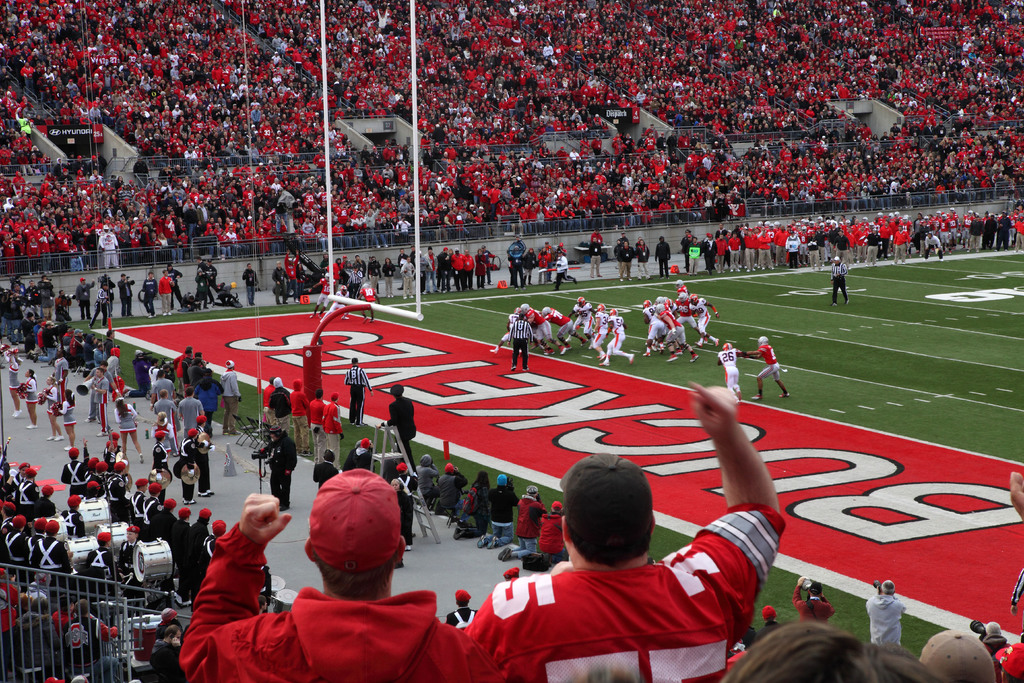How do the fans contribute to the atmosphere at the game? The fans are a vital part of the atmosphere, their collective spirit and passion evident in the sea of red attire, cheers, and focused attention on the unfolding game. They create a united and thrilling environment that boosts the players' morale and exemplifies the cultural phenomenon of American football fandom. Are there any unique traditions visible in the image that are specific to this team's fans? While specific traditions aren't clearly discernible from this image, the mass of red-clad fans, the marching band on the sideline, and the specialized painted end zone are elements that often correlate with team-specific traditions and a deep sense of community and school spirit. 